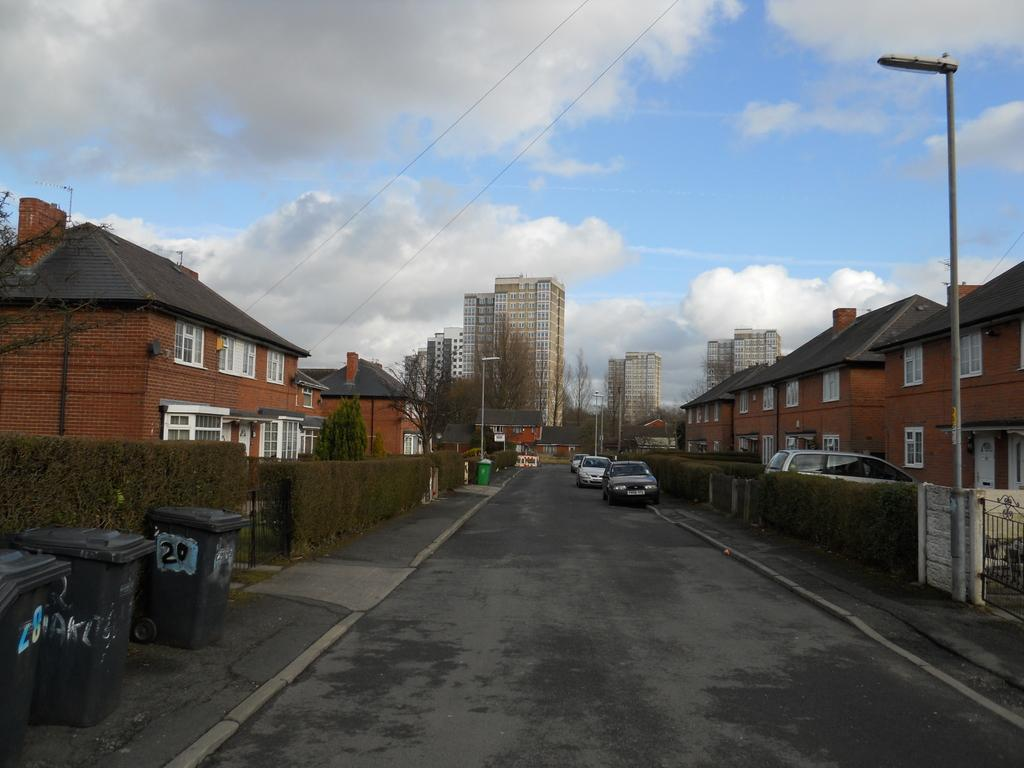What can be seen on the road in the image? There are vehicles on the road in the image. What is visible in the background of the image? There are buildings in the background of the image. What colors are the buildings? The buildings are in brown and white colors. What other object can be seen in the background of the image? There is a light pole in the background of the image. What is the color of the sky in the image? The sky is blue and white in color. Is there a store selling pumpkins in the image? There is no store or pumpkins present in the image. Is the ground covered in snow in the image? There is no snow visible in the image; the ground is not covered in snow. 